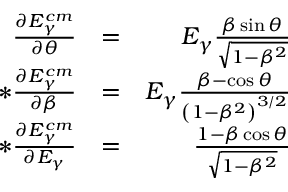<formula> <loc_0><loc_0><loc_500><loc_500>\begin{array} { r l r } { \frac { \partial E _ { \gamma } ^ { c m } } { \partial \theta } } & { = } & { E _ { \gamma } \frac { \beta \sin { \theta } } { \sqrt { 1 - \beta ^ { 2 } } } } \\ { * \frac { \partial E _ { \gamma } ^ { c m } } { \partial \beta } } & { = } & { E _ { \gamma } \frac { \beta - \cos { \theta } } { \left ( 1 - \beta ^ { 2 } \right ) ^ { 3 / 2 } } } \\ { * \frac { \partial E _ { \gamma } ^ { c m } } { \partial E _ { \gamma } } } & { = } & { \frac { 1 - \beta \cos { \theta } } { \sqrt { 1 - \beta ^ { 2 } } } } \end{array}</formula> 